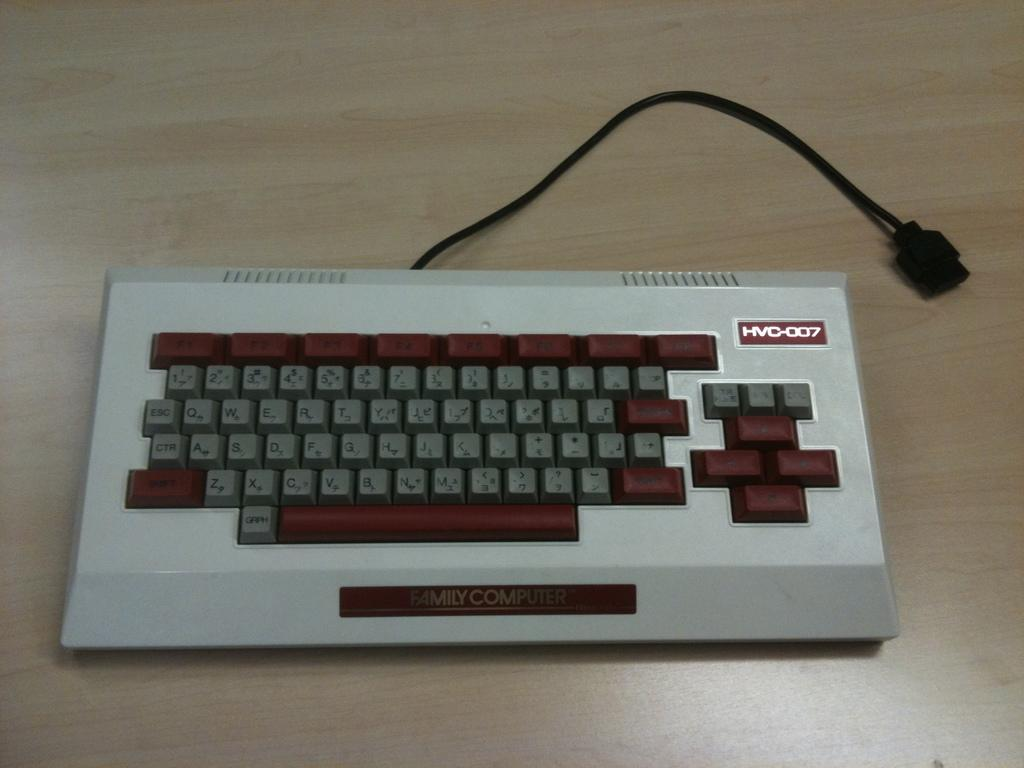<image>
Provide a brief description of the given image. HVC-0007 is the model number shown on this keyboard. 